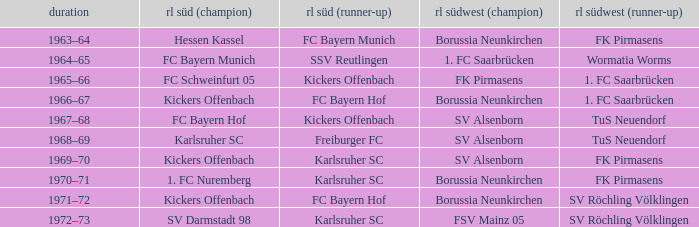What season was Freiburger FC the RL Süd (2nd) team? 1968–69. 